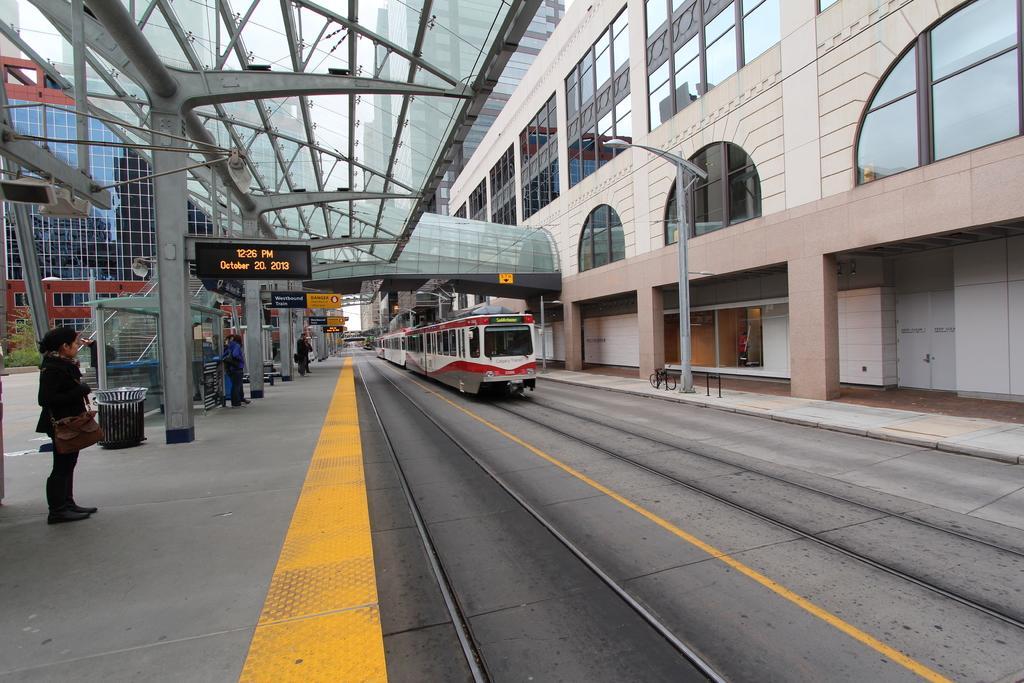In one or two sentences, can you explain what this image depicts? In this picture on the right side, we can see a train on the railway track & on the left side we can see people waiting on the platform. 